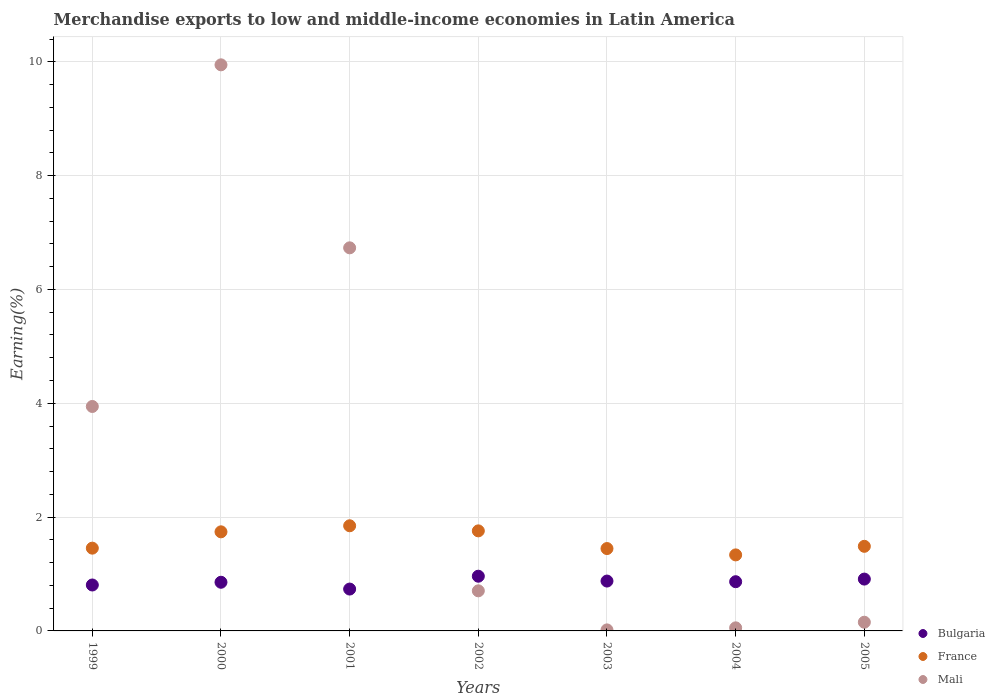Is the number of dotlines equal to the number of legend labels?
Give a very brief answer. Yes. What is the percentage of amount earned from merchandise exports in France in 2000?
Offer a very short reply. 1.74. Across all years, what is the maximum percentage of amount earned from merchandise exports in France?
Your answer should be compact. 1.85. Across all years, what is the minimum percentage of amount earned from merchandise exports in Bulgaria?
Your answer should be compact. 0.74. In which year was the percentage of amount earned from merchandise exports in Bulgaria maximum?
Keep it short and to the point. 2002. In which year was the percentage of amount earned from merchandise exports in Bulgaria minimum?
Give a very brief answer. 2001. What is the total percentage of amount earned from merchandise exports in Bulgaria in the graph?
Ensure brevity in your answer.  6.01. What is the difference between the percentage of amount earned from merchandise exports in France in 2001 and that in 2002?
Offer a terse response. 0.09. What is the difference between the percentage of amount earned from merchandise exports in France in 2003 and the percentage of amount earned from merchandise exports in Mali in 1999?
Ensure brevity in your answer.  -2.5. What is the average percentage of amount earned from merchandise exports in Mali per year?
Provide a succinct answer. 3.08. In the year 2004, what is the difference between the percentage of amount earned from merchandise exports in Bulgaria and percentage of amount earned from merchandise exports in Mali?
Offer a terse response. 0.81. In how many years, is the percentage of amount earned from merchandise exports in Mali greater than 1.6 %?
Give a very brief answer. 3. What is the ratio of the percentage of amount earned from merchandise exports in Bulgaria in 2001 to that in 2003?
Offer a terse response. 0.84. Is the percentage of amount earned from merchandise exports in Mali in 1999 less than that in 2004?
Offer a very short reply. No. Is the difference between the percentage of amount earned from merchandise exports in Bulgaria in 1999 and 2003 greater than the difference between the percentage of amount earned from merchandise exports in Mali in 1999 and 2003?
Give a very brief answer. No. What is the difference between the highest and the second highest percentage of amount earned from merchandise exports in Bulgaria?
Make the answer very short. 0.05. What is the difference between the highest and the lowest percentage of amount earned from merchandise exports in France?
Make the answer very short. 0.51. Is the percentage of amount earned from merchandise exports in France strictly greater than the percentage of amount earned from merchandise exports in Bulgaria over the years?
Keep it short and to the point. Yes. How many years are there in the graph?
Your answer should be very brief. 7. What is the difference between two consecutive major ticks on the Y-axis?
Your answer should be compact. 2. Are the values on the major ticks of Y-axis written in scientific E-notation?
Provide a short and direct response. No. Where does the legend appear in the graph?
Give a very brief answer. Bottom right. How are the legend labels stacked?
Give a very brief answer. Vertical. What is the title of the graph?
Your answer should be very brief. Merchandise exports to low and middle-income economies in Latin America. Does "Lebanon" appear as one of the legend labels in the graph?
Your answer should be very brief. No. What is the label or title of the X-axis?
Provide a short and direct response. Years. What is the label or title of the Y-axis?
Ensure brevity in your answer.  Earning(%). What is the Earning(%) in Bulgaria in 1999?
Give a very brief answer. 0.81. What is the Earning(%) in France in 1999?
Provide a succinct answer. 1.45. What is the Earning(%) of Mali in 1999?
Make the answer very short. 3.94. What is the Earning(%) of Bulgaria in 2000?
Give a very brief answer. 0.86. What is the Earning(%) of France in 2000?
Provide a short and direct response. 1.74. What is the Earning(%) of Mali in 2000?
Your answer should be compact. 9.95. What is the Earning(%) in Bulgaria in 2001?
Provide a succinct answer. 0.74. What is the Earning(%) of France in 2001?
Offer a very short reply. 1.85. What is the Earning(%) of Mali in 2001?
Make the answer very short. 6.73. What is the Earning(%) of Bulgaria in 2002?
Give a very brief answer. 0.96. What is the Earning(%) of France in 2002?
Your answer should be compact. 1.76. What is the Earning(%) in Mali in 2002?
Keep it short and to the point. 0.7. What is the Earning(%) of Bulgaria in 2003?
Your answer should be very brief. 0.88. What is the Earning(%) of France in 2003?
Offer a very short reply. 1.45. What is the Earning(%) of Mali in 2003?
Provide a succinct answer. 0.02. What is the Earning(%) of Bulgaria in 2004?
Give a very brief answer. 0.86. What is the Earning(%) in France in 2004?
Offer a very short reply. 1.34. What is the Earning(%) of Mali in 2004?
Provide a succinct answer. 0.05. What is the Earning(%) of Bulgaria in 2005?
Ensure brevity in your answer.  0.91. What is the Earning(%) in France in 2005?
Make the answer very short. 1.49. What is the Earning(%) in Mali in 2005?
Give a very brief answer. 0.15. Across all years, what is the maximum Earning(%) of Bulgaria?
Your answer should be compact. 0.96. Across all years, what is the maximum Earning(%) in France?
Your response must be concise. 1.85. Across all years, what is the maximum Earning(%) in Mali?
Your answer should be compact. 9.95. Across all years, what is the minimum Earning(%) in Bulgaria?
Provide a succinct answer. 0.74. Across all years, what is the minimum Earning(%) of France?
Provide a succinct answer. 1.34. Across all years, what is the minimum Earning(%) in Mali?
Ensure brevity in your answer.  0.02. What is the total Earning(%) of Bulgaria in the graph?
Your response must be concise. 6.01. What is the total Earning(%) of France in the graph?
Provide a short and direct response. 11.07. What is the total Earning(%) of Mali in the graph?
Provide a short and direct response. 21.55. What is the difference between the Earning(%) of Bulgaria in 1999 and that in 2000?
Provide a succinct answer. -0.05. What is the difference between the Earning(%) in France in 1999 and that in 2000?
Keep it short and to the point. -0.29. What is the difference between the Earning(%) of Mali in 1999 and that in 2000?
Keep it short and to the point. -6. What is the difference between the Earning(%) in Bulgaria in 1999 and that in 2001?
Make the answer very short. 0.07. What is the difference between the Earning(%) in France in 1999 and that in 2001?
Provide a succinct answer. -0.39. What is the difference between the Earning(%) in Mali in 1999 and that in 2001?
Make the answer very short. -2.79. What is the difference between the Earning(%) in Bulgaria in 1999 and that in 2002?
Offer a very short reply. -0.15. What is the difference between the Earning(%) of France in 1999 and that in 2002?
Offer a terse response. -0.3. What is the difference between the Earning(%) in Mali in 1999 and that in 2002?
Provide a succinct answer. 3.24. What is the difference between the Earning(%) in Bulgaria in 1999 and that in 2003?
Offer a very short reply. -0.07. What is the difference between the Earning(%) in France in 1999 and that in 2003?
Give a very brief answer. 0.01. What is the difference between the Earning(%) in Mali in 1999 and that in 2003?
Make the answer very short. 3.93. What is the difference between the Earning(%) of Bulgaria in 1999 and that in 2004?
Make the answer very short. -0.06. What is the difference between the Earning(%) in France in 1999 and that in 2004?
Your response must be concise. 0.12. What is the difference between the Earning(%) in Mali in 1999 and that in 2004?
Offer a terse response. 3.89. What is the difference between the Earning(%) of Bulgaria in 1999 and that in 2005?
Offer a very short reply. -0.1. What is the difference between the Earning(%) of France in 1999 and that in 2005?
Keep it short and to the point. -0.03. What is the difference between the Earning(%) of Mali in 1999 and that in 2005?
Provide a short and direct response. 3.79. What is the difference between the Earning(%) of Bulgaria in 2000 and that in 2001?
Offer a very short reply. 0.12. What is the difference between the Earning(%) of France in 2000 and that in 2001?
Offer a terse response. -0.11. What is the difference between the Earning(%) of Mali in 2000 and that in 2001?
Offer a very short reply. 3.22. What is the difference between the Earning(%) of Bulgaria in 2000 and that in 2002?
Your response must be concise. -0.11. What is the difference between the Earning(%) in France in 2000 and that in 2002?
Ensure brevity in your answer.  -0.02. What is the difference between the Earning(%) in Mali in 2000 and that in 2002?
Offer a very short reply. 9.24. What is the difference between the Earning(%) in Bulgaria in 2000 and that in 2003?
Keep it short and to the point. -0.02. What is the difference between the Earning(%) in France in 2000 and that in 2003?
Your response must be concise. 0.29. What is the difference between the Earning(%) in Mali in 2000 and that in 2003?
Give a very brief answer. 9.93. What is the difference between the Earning(%) in Bulgaria in 2000 and that in 2004?
Make the answer very short. -0.01. What is the difference between the Earning(%) of France in 2000 and that in 2004?
Ensure brevity in your answer.  0.41. What is the difference between the Earning(%) of Mali in 2000 and that in 2004?
Keep it short and to the point. 9.89. What is the difference between the Earning(%) in Bulgaria in 2000 and that in 2005?
Give a very brief answer. -0.06. What is the difference between the Earning(%) in France in 2000 and that in 2005?
Offer a terse response. 0.25. What is the difference between the Earning(%) in Mali in 2000 and that in 2005?
Give a very brief answer. 9.79. What is the difference between the Earning(%) in Bulgaria in 2001 and that in 2002?
Provide a succinct answer. -0.23. What is the difference between the Earning(%) in France in 2001 and that in 2002?
Provide a short and direct response. 0.09. What is the difference between the Earning(%) of Mali in 2001 and that in 2002?
Offer a very short reply. 6.03. What is the difference between the Earning(%) in Bulgaria in 2001 and that in 2003?
Make the answer very short. -0.14. What is the difference between the Earning(%) of France in 2001 and that in 2003?
Your answer should be very brief. 0.4. What is the difference between the Earning(%) of Mali in 2001 and that in 2003?
Your answer should be very brief. 6.71. What is the difference between the Earning(%) in Bulgaria in 2001 and that in 2004?
Provide a short and direct response. -0.13. What is the difference between the Earning(%) in France in 2001 and that in 2004?
Offer a terse response. 0.51. What is the difference between the Earning(%) of Mali in 2001 and that in 2004?
Keep it short and to the point. 6.68. What is the difference between the Earning(%) of Bulgaria in 2001 and that in 2005?
Offer a very short reply. -0.18. What is the difference between the Earning(%) in France in 2001 and that in 2005?
Provide a succinct answer. 0.36. What is the difference between the Earning(%) of Mali in 2001 and that in 2005?
Your answer should be compact. 6.58. What is the difference between the Earning(%) of Bulgaria in 2002 and that in 2003?
Ensure brevity in your answer.  0.09. What is the difference between the Earning(%) of France in 2002 and that in 2003?
Ensure brevity in your answer.  0.31. What is the difference between the Earning(%) in Mali in 2002 and that in 2003?
Offer a very short reply. 0.69. What is the difference between the Earning(%) in Bulgaria in 2002 and that in 2004?
Provide a succinct answer. 0.1. What is the difference between the Earning(%) of France in 2002 and that in 2004?
Provide a short and direct response. 0.42. What is the difference between the Earning(%) of Mali in 2002 and that in 2004?
Provide a short and direct response. 0.65. What is the difference between the Earning(%) of Bulgaria in 2002 and that in 2005?
Offer a very short reply. 0.05. What is the difference between the Earning(%) in France in 2002 and that in 2005?
Make the answer very short. 0.27. What is the difference between the Earning(%) in Mali in 2002 and that in 2005?
Your answer should be very brief. 0.55. What is the difference between the Earning(%) of Bulgaria in 2003 and that in 2004?
Your answer should be very brief. 0.01. What is the difference between the Earning(%) of France in 2003 and that in 2004?
Make the answer very short. 0.11. What is the difference between the Earning(%) of Mali in 2003 and that in 2004?
Give a very brief answer. -0.04. What is the difference between the Earning(%) of Bulgaria in 2003 and that in 2005?
Ensure brevity in your answer.  -0.03. What is the difference between the Earning(%) in France in 2003 and that in 2005?
Provide a succinct answer. -0.04. What is the difference between the Earning(%) of Mali in 2003 and that in 2005?
Your answer should be compact. -0.13. What is the difference between the Earning(%) in Bulgaria in 2004 and that in 2005?
Make the answer very short. -0.05. What is the difference between the Earning(%) of France in 2004 and that in 2005?
Provide a short and direct response. -0.15. What is the difference between the Earning(%) in Mali in 2004 and that in 2005?
Offer a terse response. -0.1. What is the difference between the Earning(%) in Bulgaria in 1999 and the Earning(%) in France in 2000?
Provide a short and direct response. -0.93. What is the difference between the Earning(%) in Bulgaria in 1999 and the Earning(%) in Mali in 2000?
Your answer should be very brief. -9.14. What is the difference between the Earning(%) of France in 1999 and the Earning(%) of Mali in 2000?
Offer a very short reply. -8.49. What is the difference between the Earning(%) of Bulgaria in 1999 and the Earning(%) of France in 2001?
Provide a succinct answer. -1.04. What is the difference between the Earning(%) of Bulgaria in 1999 and the Earning(%) of Mali in 2001?
Keep it short and to the point. -5.92. What is the difference between the Earning(%) in France in 1999 and the Earning(%) in Mali in 2001?
Your answer should be very brief. -5.28. What is the difference between the Earning(%) in Bulgaria in 1999 and the Earning(%) in France in 2002?
Your answer should be very brief. -0.95. What is the difference between the Earning(%) in Bulgaria in 1999 and the Earning(%) in Mali in 2002?
Keep it short and to the point. 0.1. What is the difference between the Earning(%) in France in 1999 and the Earning(%) in Mali in 2002?
Provide a short and direct response. 0.75. What is the difference between the Earning(%) of Bulgaria in 1999 and the Earning(%) of France in 2003?
Offer a terse response. -0.64. What is the difference between the Earning(%) of Bulgaria in 1999 and the Earning(%) of Mali in 2003?
Make the answer very short. 0.79. What is the difference between the Earning(%) of France in 1999 and the Earning(%) of Mali in 2003?
Provide a succinct answer. 1.44. What is the difference between the Earning(%) of Bulgaria in 1999 and the Earning(%) of France in 2004?
Ensure brevity in your answer.  -0.53. What is the difference between the Earning(%) in Bulgaria in 1999 and the Earning(%) in Mali in 2004?
Ensure brevity in your answer.  0.75. What is the difference between the Earning(%) of France in 1999 and the Earning(%) of Mali in 2004?
Your response must be concise. 1.4. What is the difference between the Earning(%) of Bulgaria in 1999 and the Earning(%) of France in 2005?
Keep it short and to the point. -0.68. What is the difference between the Earning(%) in Bulgaria in 1999 and the Earning(%) in Mali in 2005?
Offer a terse response. 0.65. What is the difference between the Earning(%) of France in 1999 and the Earning(%) of Mali in 2005?
Offer a very short reply. 1.3. What is the difference between the Earning(%) in Bulgaria in 2000 and the Earning(%) in France in 2001?
Ensure brevity in your answer.  -0.99. What is the difference between the Earning(%) of Bulgaria in 2000 and the Earning(%) of Mali in 2001?
Your response must be concise. -5.88. What is the difference between the Earning(%) in France in 2000 and the Earning(%) in Mali in 2001?
Your response must be concise. -4.99. What is the difference between the Earning(%) in Bulgaria in 2000 and the Earning(%) in France in 2002?
Give a very brief answer. -0.9. What is the difference between the Earning(%) of Bulgaria in 2000 and the Earning(%) of Mali in 2002?
Your response must be concise. 0.15. What is the difference between the Earning(%) in France in 2000 and the Earning(%) in Mali in 2002?
Give a very brief answer. 1.04. What is the difference between the Earning(%) of Bulgaria in 2000 and the Earning(%) of France in 2003?
Provide a succinct answer. -0.59. What is the difference between the Earning(%) of Bulgaria in 2000 and the Earning(%) of Mali in 2003?
Your response must be concise. 0.84. What is the difference between the Earning(%) of France in 2000 and the Earning(%) of Mali in 2003?
Your answer should be very brief. 1.72. What is the difference between the Earning(%) in Bulgaria in 2000 and the Earning(%) in France in 2004?
Give a very brief answer. -0.48. What is the difference between the Earning(%) in Bulgaria in 2000 and the Earning(%) in Mali in 2004?
Provide a succinct answer. 0.8. What is the difference between the Earning(%) in France in 2000 and the Earning(%) in Mali in 2004?
Keep it short and to the point. 1.69. What is the difference between the Earning(%) of Bulgaria in 2000 and the Earning(%) of France in 2005?
Make the answer very short. -0.63. What is the difference between the Earning(%) in Bulgaria in 2000 and the Earning(%) in Mali in 2005?
Provide a short and direct response. 0.7. What is the difference between the Earning(%) in France in 2000 and the Earning(%) in Mali in 2005?
Keep it short and to the point. 1.59. What is the difference between the Earning(%) of Bulgaria in 2001 and the Earning(%) of France in 2002?
Your response must be concise. -1.02. What is the difference between the Earning(%) of Bulgaria in 2001 and the Earning(%) of Mali in 2002?
Provide a succinct answer. 0.03. What is the difference between the Earning(%) in France in 2001 and the Earning(%) in Mali in 2002?
Offer a terse response. 1.14. What is the difference between the Earning(%) in Bulgaria in 2001 and the Earning(%) in France in 2003?
Your response must be concise. -0.71. What is the difference between the Earning(%) in Bulgaria in 2001 and the Earning(%) in Mali in 2003?
Your answer should be very brief. 0.72. What is the difference between the Earning(%) in France in 2001 and the Earning(%) in Mali in 2003?
Ensure brevity in your answer.  1.83. What is the difference between the Earning(%) of Bulgaria in 2001 and the Earning(%) of France in 2004?
Your response must be concise. -0.6. What is the difference between the Earning(%) of Bulgaria in 2001 and the Earning(%) of Mali in 2004?
Give a very brief answer. 0.68. What is the difference between the Earning(%) in France in 2001 and the Earning(%) in Mali in 2004?
Ensure brevity in your answer.  1.79. What is the difference between the Earning(%) of Bulgaria in 2001 and the Earning(%) of France in 2005?
Give a very brief answer. -0.75. What is the difference between the Earning(%) of Bulgaria in 2001 and the Earning(%) of Mali in 2005?
Give a very brief answer. 0.58. What is the difference between the Earning(%) in France in 2001 and the Earning(%) in Mali in 2005?
Keep it short and to the point. 1.69. What is the difference between the Earning(%) of Bulgaria in 2002 and the Earning(%) of France in 2003?
Your answer should be very brief. -0.49. What is the difference between the Earning(%) of Bulgaria in 2002 and the Earning(%) of Mali in 2003?
Ensure brevity in your answer.  0.94. What is the difference between the Earning(%) of France in 2002 and the Earning(%) of Mali in 2003?
Your answer should be compact. 1.74. What is the difference between the Earning(%) in Bulgaria in 2002 and the Earning(%) in France in 2004?
Give a very brief answer. -0.37. What is the difference between the Earning(%) in Bulgaria in 2002 and the Earning(%) in Mali in 2004?
Your answer should be very brief. 0.91. What is the difference between the Earning(%) of France in 2002 and the Earning(%) of Mali in 2004?
Your answer should be very brief. 1.7. What is the difference between the Earning(%) in Bulgaria in 2002 and the Earning(%) in France in 2005?
Provide a succinct answer. -0.53. What is the difference between the Earning(%) in Bulgaria in 2002 and the Earning(%) in Mali in 2005?
Your answer should be compact. 0.81. What is the difference between the Earning(%) of France in 2002 and the Earning(%) of Mali in 2005?
Your answer should be very brief. 1.61. What is the difference between the Earning(%) in Bulgaria in 2003 and the Earning(%) in France in 2004?
Your response must be concise. -0.46. What is the difference between the Earning(%) of Bulgaria in 2003 and the Earning(%) of Mali in 2004?
Your response must be concise. 0.82. What is the difference between the Earning(%) in France in 2003 and the Earning(%) in Mali in 2004?
Offer a terse response. 1.39. What is the difference between the Earning(%) in Bulgaria in 2003 and the Earning(%) in France in 2005?
Your response must be concise. -0.61. What is the difference between the Earning(%) of Bulgaria in 2003 and the Earning(%) of Mali in 2005?
Ensure brevity in your answer.  0.72. What is the difference between the Earning(%) in France in 2003 and the Earning(%) in Mali in 2005?
Your answer should be compact. 1.29. What is the difference between the Earning(%) of Bulgaria in 2004 and the Earning(%) of France in 2005?
Give a very brief answer. -0.62. What is the difference between the Earning(%) in Bulgaria in 2004 and the Earning(%) in Mali in 2005?
Offer a very short reply. 0.71. What is the difference between the Earning(%) in France in 2004 and the Earning(%) in Mali in 2005?
Your response must be concise. 1.18. What is the average Earning(%) in Bulgaria per year?
Give a very brief answer. 0.86. What is the average Earning(%) in France per year?
Keep it short and to the point. 1.58. What is the average Earning(%) in Mali per year?
Your answer should be very brief. 3.08. In the year 1999, what is the difference between the Earning(%) of Bulgaria and Earning(%) of France?
Offer a terse response. -0.65. In the year 1999, what is the difference between the Earning(%) in Bulgaria and Earning(%) in Mali?
Ensure brevity in your answer.  -3.14. In the year 1999, what is the difference between the Earning(%) of France and Earning(%) of Mali?
Ensure brevity in your answer.  -2.49. In the year 2000, what is the difference between the Earning(%) in Bulgaria and Earning(%) in France?
Provide a short and direct response. -0.89. In the year 2000, what is the difference between the Earning(%) in Bulgaria and Earning(%) in Mali?
Your answer should be very brief. -9.09. In the year 2000, what is the difference between the Earning(%) of France and Earning(%) of Mali?
Ensure brevity in your answer.  -8.21. In the year 2001, what is the difference between the Earning(%) of Bulgaria and Earning(%) of France?
Your response must be concise. -1.11. In the year 2001, what is the difference between the Earning(%) in Bulgaria and Earning(%) in Mali?
Keep it short and to the point. -6. In the year 2001, what is the difference between the Earning(%) in France and Earning(%) in Mali?
Ensure brevity in your answer.  -4.88. In the year 2002, what is the difference between the Earning(%) of Bulgaria and Earning(%) of France?
Keep it short and to the point. -0.8. In the year 2002, what is the difference between the Earning(%) in Bulgaria and Earning(%) in Mali?
Keep it short and to the point. 0.26. In the year 2002, what is the difference between the Earning(%) of France and Earning(%) of Mali?
Provide a short and direct response. 1.05. In the year 2003, what is the difference between the Earning(%) in Bulgaria and Earning(%) in France?
Make the answer very short. -0.57. In the year 2003, what is the difference between the Earning(%) in Bulgaria and Earning(%) in Mali?
Keep it short and to the point. 0.86. In the year 2003, what is the difference between the Earning(%) in France and Earning(%) in Mali?
Your answer should be very brief. 1.43. In the year 2004, what is the difference between the Earning(%) of Bulgaria and Earning(%) of France?
Ensure brevity in your answer.  -0.47. In the year 2004, what is the difference between the Earning(%) in Bulgaria and Earning(%) in Mali?
Ensure brevity in your answer.  0.81. In the year 2004, what is the difference between the Earning(%) in France and Earning(%) in Mali?
Make the answer very short. 1.28. In the year 2005, what is the difference between the Earning(%) in Bulgaria and Earning(%) in France?
Your response must be concise. -0.58. In the year 2005, what is the difference between the Earning(%) in Bulgaria and Earning(%) in Mali?
Keep it short and to the point. 0.76. In the year 2005, what is the difference between the Earning(%) in France and Earning(%) in Mali?
Ensure brevity in your answer.  1.33. What is the ratio of the Earning(%) in Bulgaria in 1999 to that in 2000?
Your response must be concise. 0.94. What is the ratio of the Earning(%) of France in 1999 to that in 2000?
Provide a short and direct response. 0.84. What is the ratio of the Earning(%) in Mali in 1999 to that in 2000?
Offer a very short reply. 0.4. What is the ratio of the Earning(%) of Bulgaria in 1999 to that in 2001?
Ensure brevity in your answer.  1.1. What is the ratio of the Earning(%) of France in 1999 to that in 2001?
Ensure brevity in your answer.  0.79. What is the ratio of the Earning(%) in Mali in 1999 to that in 2001?
Provide a succinct answer. 0.59. What is the ratio of the Earning(%) of Bulgaria in 1999 to that in 2002?
Your answer should be very brief. 0.84. What is the ratio of the Earning(%) in France in 1999 to that in 2002?
Your response must be concise. 0.83. What is the ratio of the Earning(%) in Mali in 1999 to that in 2002?
Ensure brevity in your answer.  5.6. What is the ratio of the Earning(%) in Bulgaria in 1999 to that in 2003?
Offer a very short reply. 0.92. What is the ratio of the Earning(%) of France in 1999 to that in 2003?
Offer a very short reply. 1. What is the ratio of the Earning(%) in Mali in 1999 to that in 2003?
Provide a succinct answer. 219.84. What is the ratio of the Earning(%) of Bulgaria in 1999 to that in 2004?
Offer a terse response. 0.93. What is the ratio of the Earning(%) of France in 1999 to that in 2004?
Keep it short and to the point. 1.09. What is the ratio of the Earning(%) of Mali in 1999 to that in 2004?
Your response must be concise. 72.87. What is the ratio of the Earning(%) of Bulgaria in 1999 to that in 2005?
Ensure brevity in your answer.  0.89. What is the ratio of the Earning(%) in France in 1999 to that in 2005?
Give a very brief answer. 0.98. What is the ratio of the Earning(%) of Mali in 1999 to that in 2005?
Provide a short and direct response. 25.83. What is the ratio of the Earning(%) in Bulgaria in 2000 to that in 2001?
Offer a very short reply. 1.16. What is the ratio of the Earning(%) in France in 2000 to that in 2001?
Make the answer very short. 0.94. What is the ratio of the Earning(%) of Mali in 2000 to that in 2001?
Your answer should be compact. 1.48. What is the ratio of the Earning(%) in Bulgaria in 2000 to that in 2002?
Your answer should be very brief. 0.89. What is the ratio of the Earning(%) of France in 2000 to that in 2002?
Give a very brief answer. 0.99. What is the ratio of the Earning(%) in Mali in 2000 to that in 2002?
Offer a terse response. 14.12. What is the ratio of the Earning(%) of Bulgaria in 2000 to that in 2003?
Offer a very short reply. 0.98. What is the ratio of the Earning(%) in France in 2000 to that in 2003?
Your answer should be very brief. 1.2. What is the ratio of the Earning(%) of Mali in 2000 to that in 2003?
Provide a short and direct response. 554.47. What is the ratio of the Earning(%) of Bulgaria in 2000 to that in 2004?
Provide a short and direct response. 0.99. What is the ratio of the Earning(%) of France in 2000 to that in 2004?
Keep it short and to the point. 1.3. What is the ratio of the Earning(%) in Mali in 2000 to that in 2004?
Your response must be concise. 183.79. What is the ratio of the Earning(%) in Bulgaria in 2000 to that in 2005?
Your answer should be compact. 0.94. What is the ratio of the Earning(%) of France in 2000 to that in 2005?
Offer a terse response. 1.17. What is the ratio of the Earning(%) of Mali in 2000 to that in 2005?
Your response must be concise. 65.14. What is the ratio of the Earning(%) of Bulgaria in 2001 to that in 2002?
Provide a short and direct response. 0.77. What is the ratio of the Earning(%) of France in 2001 to that in 2002?
Keep it short and to the point. 1.05. What is the ratio of the Earning(%) of Mali in 2001 to that in 2002?
Your answer should be very brief. 9.56. What is the ratio of the Earning(%) in Bulgaria in 2001 to that in 2003?
Your answer should be compact. 0.84. What is the ratio of the Earning(%) in France in 2001 to that in 2003?
Offer a terse response. 1.28. What is the ratio of the Earning(%) in Mali in 2001 to that in 2003?
Keep it short and to the point. 375.23. What is the ratio of the Earning(%) of Bulgaria in 2001 to that in 2004?
Offer a very short reply. 0.85. What is the ratio of the Earning(%) in France in 2001 to that in 2004?
Ensure brevity in your answer.  1.38. What is the ratio of the Earning(%) of Mali in 2001 to that in 2004?
Make the answer very short. 124.38. What is the ratio of the Earning(%) in Bulgaria in 2001 to that in 2005?
Your answer should be very brief. 0.81. What is the ratio of the Earning(%) of France in 2001 to that in 2005?
Offer a very short reply. 1.24. What is the ratio of the Earning(%) of Mali in 2001 to that in 2005?
Your response must be concise. 44.08. What is the ratio of the Earning(%) in Bulgaria in 2002 to that in 2003?
Offer a very short reply. 1.1. What is the ratio of the Earning(%) of France in 2002 to that in 2003?
Offer a very short reply. 1.21. What is the ratio of the Earning(%) of Mali in 2002 to that in 2003?
Keep it short and to the point. 39.27. What is the ratio of the Earning(%) of Bulgaria in 2002 to that in 2004?
Keep it short and to the point. 1.11. What is the ratio of the Earning(%) in France in 2002 to that in 2004?
Your response must be concise. 1.32. What is the ratio of the Earning(%) of Mali in 2002 to that in 2004?
Provide a short and direct response. 13.02. What is the ratio of the Earning(%) in Bulgaria in 2002 to that in 2005?
Your response must be concise. 1.06. What is the ratio of the Earning(%) in France in 2002 to that in 2005?
Offer a terse response. 1.18. What is the ratio of the Earning(%) of Mali in 2002 to that in 2005?
Your response must be concise. 4.61. What is the ratio of the Earning(%) in Bulgaria in 2003 to that in 2004?
Provide a short and direct response. 1.01. What is the ratio of the Earning(%) of France in 2003 to that in 2004?
Provide a short and direct response. 1.08. What is the ratio of the Earning(%) in Mali in 2003 to that in 2004?
Provide a short and direct response. 0.33. What is the ratio of the Earning(%) in Bulgaria in 2003 to that in 2005?
Make the answer very short. 0.96. What is the ratio of the Earning(%) of France in 2003 to that in 2005?
Ensure brevity in your answer.  0.97. What is the ratio of the Earning(%) of Mali in 2003 to that in 2005?
Provide a short and direct response. 0.12. What is the ratio of the Earning(%) of Bulgaria in 2004 to that in 2005?
Offer a very short reply. 0.95. What is the ratio of the Earning(%) in France in 2004 to that in 2005?
Offer a terse response. 0.9. What is the ratio of the Earning(%) of Mali in 2004 to that in 2005?
Provide a succinct answer. 0.35. What is the difference between the highest and the second highest Earning(%) of Bulgaria?
Offer a very short reply. 0.05. What is the difference between the highest and the second highest Earning(%) of France?
Make the answer very short. 0.09. What is the difference between the highest and the second highest Earning(%) in Mali?
Your answer should be compact. 3.22. What is the difference between the highest and the lowest Earning(%) of Bulgaria?
Offer a very short reply. 0.23. What is the difference between the highest and the lowest Earning(%) of France?
Ensure brevity in your answer.  0.51. What is the difference between the highest and the lowest Earning(%) in Mali?
Your answer should be compact. 9.93. 